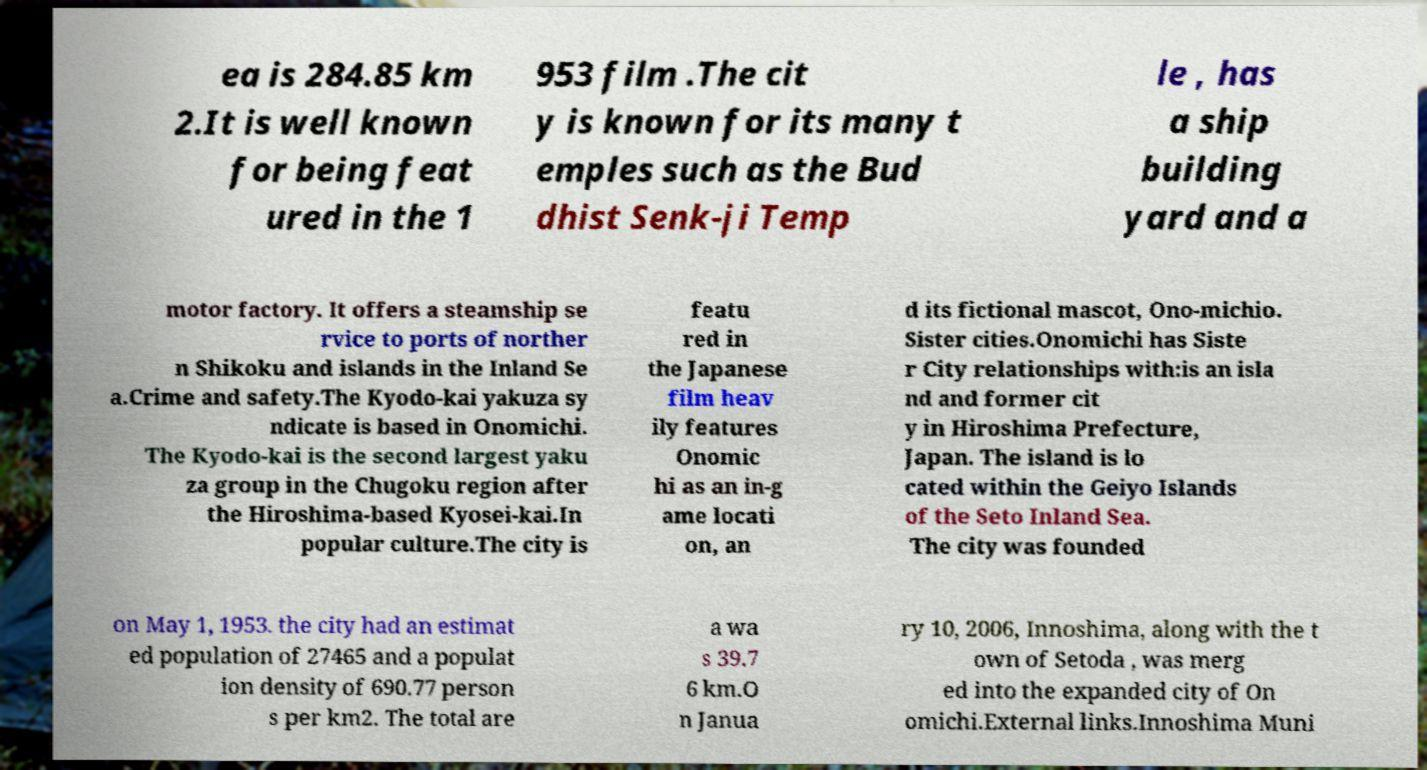Can you accurately transcribe the text from the provided image for me? ea is 284.85 km 2.It is well known for being feat ured in the 1 953 film .The cit y is known for its many t emples such as the Bud dhist Senk-ji Temp le , has a ship building yard and a motor factory. It offers a steamship se rvice to ports of norther n Shikoku and islands in the Inland Se a.Crime and safety.The Kyodo-kai yakuza sy ndicate is based in Onomichi. The Kyodo-kai is the second largest yaku za group in the Chugoku region after the Hiroshima-based Kyosei-kai.In popular culture.The city is featu red in the Japanese film heav ily features Onomic hi as an in-g ame locati on, an d its fictional mascot, Ono-michio. Sister cities.Onomichi has Siste r City relationships with:is an isla nd and former cit y in Hiroshima Prefecture, Japan. The island is lo cated within the Geiyo Islands of the Seto Inland Sea. The city was founded on May 1, 1953. the city had an estimat ed population of 27465 and a populat ion density of 690.77 person s per km2. The total are a wa s 39.7 6 km.O n Janua ry 10, 2006, Innoshima, along with the t own of Setoda , was merg ed into the expanded city of On omichi.External links.Innoshima Muni 